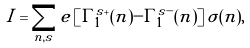<formula> <loc_0><loc_0><loc_500><loc_500>I = \sum _ { n , s } e \left [ \Gamma _ { 1 } ^ { s + } ( n ) - \Gamma _ { 1 } ^ { s - } ( n ) \right ] \sigma ( n ) ,</formula> 